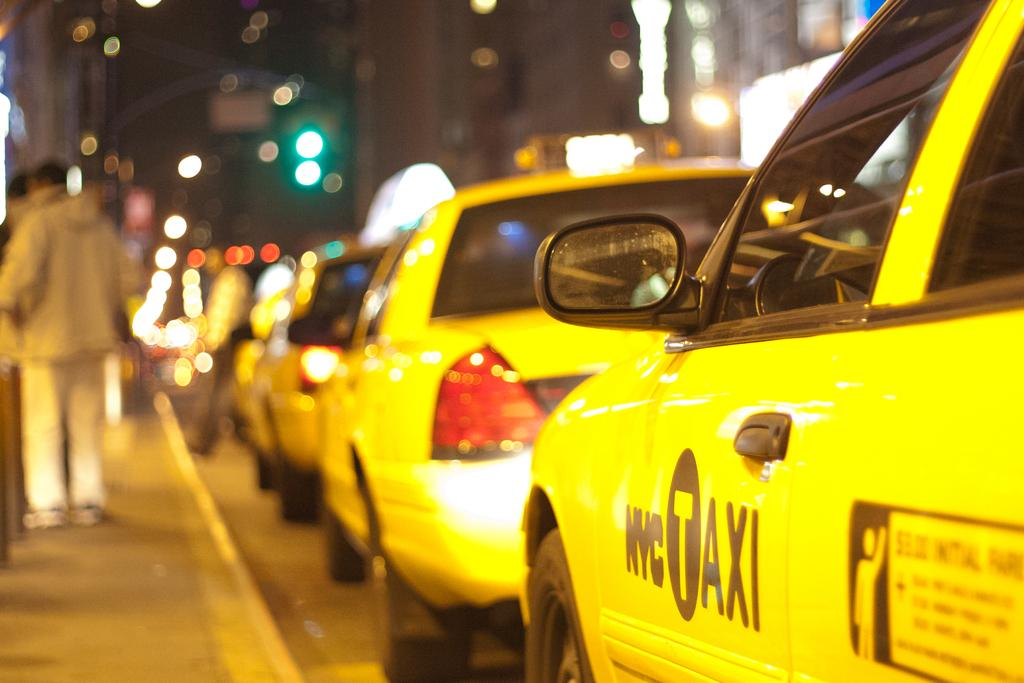<image>
Provide a brief description of the given image. A yellow taxi which has the letters NYC on it. 